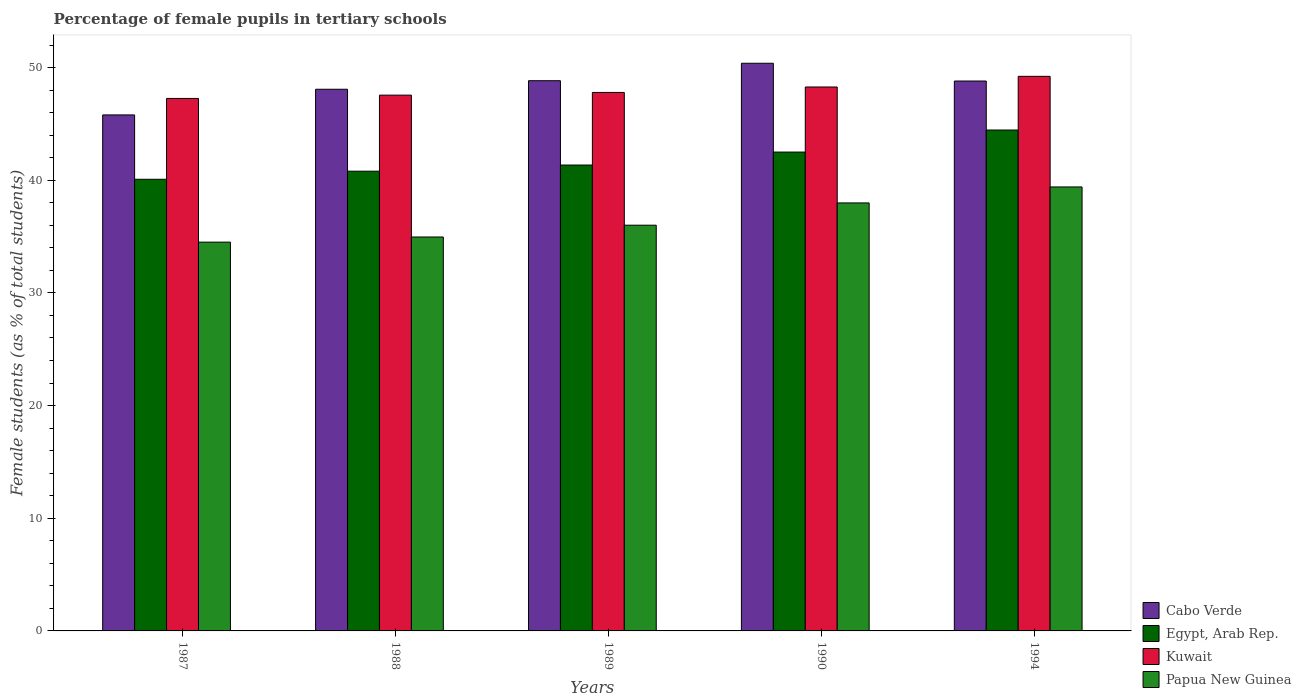Are the number of bars per tick equal to the number of legend labels?
Keep it short and to the point. Yes. Are the number of bars on each tick of the X-axis equal?
Keep it short and to the point. Yes. How many bars are there on the 3rd tick from the left?
Provide a succinct answer. 4. In how many cases, is the number of bars for a given year not equal to the number of legend labels?
Offer a very short reply. 0. What is the percentage of female pupils in tertiary schools in Papua New Guinea in 1990?
Provide a succinct answer. 37.99. Across all years, what is the maximum percentage of female pupils in tertiary schools in Papua New Guinea?
Provide a short and direct response. 39.4. Across all years, what is the minimum percentage of female pupils in tertiary schools in Papua New Guinea?
Provide a succinct answer. 34.51. In which year was the percentage of female pupils in tertiary schools in Kuwait maximum?
Your response must be concise. 1994. In which year was the percentage of female pupils in tertiary schools in Papua New Guinea minimum?
Offer a terse response. 1987. What is the total percentage of female pupils in tertiary schools in Papua New Guinea in the graph?
Give a very brief answer. 182.87. What is the difference between the percentage of female pupils in tertiary schools in Egypt, Arab Rep. in 1989 and that in 1994?
Ensure brevity in your answer.  -3.11. What is the difference between the percentage of female pupils in tertiary schools in Cabo Verde in 1994 and the percentage of female pupils in tertiary schools in Papua New Guinea in 1990?
Ensure brevity in your answer.  10.82. What is the average percentage of female pupils in tertiary schools in Papua New Guinea per year?
Keep it short and to the point. 36.57. In the year 1990, what is the difference between the percentage of female pupils in tertiary schools in Kuwait and percentage of female pupils in tertiary schools in Cabo Verde?
Make the answer very short. -2.11. What is the ratio of the percentage of female pupils in tertiary schools in Egypt, Arab Rep. in 1987 to that in 1994?
Give a very brief answer. 0.9. Is the percentage of female pupils in tertiary schools in Egypt, Arab Rep. in 1987 less than that in 1990?
Your answer should be compact. Yes. What is the difference between the highest and the second highest percentage of female pupils in tertiary schools in Egypt, Arab Rep.?
Give a very brief answer. 1.96. What is the difference between the highest and the lowest percentage of female pupils in tertiary schools in Kuwait?
Make the answer very short. 1.96. In how many years, is the percentage of female pupils in tertiary schools in Papua New Guinea greater than the average percentage of female pupils in tertiary schools in Papua New Guinea taken over all years?
Offer a very short reply. 2. Is the sum of the percentage of female pupils in tertiary schools in Cabo Verde in 1988 and 1990 greater than the maximum percentage of female pupils in tertiary schools in Egypt, Arab Rep. across all years?
Your answer should be very brief. Yes. What does the 4th bar from the left in 1994 represents?
Your answer should be very brief. Papua New Guinea. What does the 2nd bar from the right in 1988 represents?
Keep it short and to the point. Kuwait. How many bars are there?
Keep it short and to the point. 20. How many years are there in the graph?
Give a very brief answer. 5. What is the difference between two consecutive major ticks on the Y-axis?
Give a very brief answer. 10. Does the graph contain any zero values?
Provide a short and direct response. No. Does the graph contain grids?
Make the answer very short. No. What is the title of the graph?
Offer a very short reply. Percentage of female pupils in tertiary schools. What is the label or title of the X-axis?
Provide a succinct answer. Years. What is the label or title of the Y-axis?
Make the answer very short. Female students (as % of total students). What is the Female students (as % of total students) in Cabo Verde in 1987?
Provide a succinct answer. 45.8. What is the Female students (as % of total students) of Egypt, Arab Rep. in 1987?
Your response must be concise. 40.08. What is the Female students (as % of total students) in Kuwait in 1987?
Offer a terse response. 47.26. What is the Female students (as % of total students) in Papua New Guinea in 1987?
Ensure brevity in your answer.  34.51. What is the Female students (as % of total students) in Cabo Verde in 1988?
Give a very brief answer. 48.07. What is the Female students (as % of total students) of Egypt, Arab Rep. in 1988?
Offer a terse response. 40.8. What is the Female students (as % of total students) in Kuwait in 1988?
Offer a very short reply. 47.55. What is the Female students (as % of total students) in Papua New Guinea in 1988?
Your answer should be very brief. 34.96. What is the Female students (as % of total students) in Cabo Verde in 1989?
Offer a very short reply. 48.83. What is the Female students (as % of total students) in Egypt, Arab Rep. in 1989?
Keep it short and to the point. 41.35. What is the Female students (as % of total students) of Kuwait in 1989?
Keep it short and to the point. 47.79. What is the Female students (as % of total students) in Papua New Guinea in 1989?
Provide a succinct answer. 36.01. What is the Female students (as % of total students) of Cabo Verde in 1990?
Your response must be concise. 50.38. What is the Female students (as % of total students) in Egypt, Arab Rep. in 1990?
Your answer should be compact. 42.5. What is the Female students (as % of total students) of Kuwait in 1990?
Your answer should be very brief. 48.28. What is the Female students (as % of total students) in Papua New Guinea in 1990?
Offer a very short reply. 37.99. What is the Female students (as % of total students) in Cabo Verde in 1994?
Provide a succinct answer. 48.8. What is the Female students (as % of total students) of Egypt, Arab Rep. in 1994?
Provide a succinct answer. 44.46. What is the Female students (as % of total students) in Kuwait in 1994?
Give a very brief answer. 49.22. What is the Female students (as % of total students) in Papua New Guinea in 1994?
Provide a succinct answer. 39.4. Across all years, what is the maximum Female students (as % of total students) in Cabo Verde?
Offer a very short reply. 50.38. Across all years, what is the maximum Female students (as % of total students) in Egypt, Arab Rep.?
Give a very brief answer. 44.46. Across all years, what is the maximum Female students (as % of total students) of Kuwait?
Your answer should be compact. 49.22. Across all years, what is the maximum Female students (as % of total students) of Papua New Guinea?
Offer a terse response. 39.4. Across all years, what is the minimum Female students (as % of total students) in Cabo Verde?
Provide a short and direct response. 45.8. Across all years, what is the minimum Female students (as % of total students) of Egypt, Arab Rep.?
Your response must be concise. 40.08. Across all years, what is the minimum Female students (as % of total students) of Kuwait?
Provide a short and direct response. 47.26. Across all years, what is the minimum Female students (as % of total students) of Papua New Guinea?
Provide a succinct answer. 34.51. What is the total Female students (as % of total students) in Cabo Verde in the graph?
Give a very brief answer. 241.89. What is the total Female students (as % of total students) of Egypt, Arab Rep. in the graph?
Provide a short and direct response. 209.19. What is the total Female students (as % of total students) of Kuwait in the graph?
Your answer should be very brief. 240.1. What is the total Female students (as % of total students) in Papua New Guinea in the graph?
Your answer should be very brief. 182.87. What is the difference between the Female students (as % of total students) in Cabo Verde in 1987 and that in 1988?
Provide a short and direct response. -2.28. What is the difference between the Female students (as % of total students) in Egypt, Arab Rep. in 1987 and that in 1988?
Provide a succinct answer. -0.72. What is the difference between the Female students (as % of total students) in Kuwait in 1987 and that in 1988?
Keep it short and to the point. -0.29. What is the difference between the Female students (as % of total students) of Papua New Guinea in 1987 and that in 1988?
Your answer should be very brief. -0.46. What is the difference between the Female students (as % of total students) of Cabo Verde in 1987 and that in 1989?
Your response must be concise. -3.03. What is the difference between the Female students (as % of total students) in Egypt, Arab Rep. in 1987 and that in 1989?
Make the answer very short. -1.26. What is the difference between the Female students (as % of total students) in Kuwait in 1987 and that in 1989?
Your answer should be compact. -0.53. What is the difference between the Female students (as % of total students) in Papua New Guinea in 1987 and that in 1989?
Your response must be concise. -1.5. What is the difference between the Female students (as % of total students) of Cabo Verde in 1987 and that in 1990?
Ensure brevity in your answer.  -4.58. What is the difference between the Female students (as % of total students) of Egypt, Arab Rep. in 1987 and that in 1990?
Offer a very short reply. -2.42. What is the difference between the Female students (as % of total students) in Kuwait in 1987 and that in 1990?
Give a very brief answer. -1.02. What is the difference between the Female students (as % of total students) of Papua New Guinea in 1987 and that in 1990?
Provide a succinct answer. -3.48. What is the difference between the Female students (as % of total students) in Cabo Verde in 1987 and that in 1994?
Make the answer very short. -3.01. What is the difference between the Female students (as % of total students) in Egypt, Arab Rep. in 1987 and that in 1994?
Make the answer very short. -4.37. What is the difference between the Female students (as % of total students) in Kuwait in 1987 and that in 1994?
Ensure brevity in your answer.  -1.96. What is the difference between the Female students (as % of total students) of Papua New Guinea in 1987 and that in 1994?
Make the answer very short. -4.9. What is the difference between the Female students (as % of total students) of Cabo Verde in 1988 and that in 1989?
Make the answer very short. -0.76. What is the difference between the Female students (as % of total students) of Egypt, Arab Rep. in 1988 and that in 1989?
Your answer should be very brief. -0.55. What is the difference between the Female students (as % of total students) of Kuwait in 1988 and that in 1989?
Ensure brevity in your answer.  -0.24. What is the difference between the Female students (as % of total students) of Papua New Guinea in 1988 and that in 1989?
Provide a succinct answer. -1.05. What is the difference between the Female students (as % of total students) of Cabo Verde in 1988 and that in 1990?
Your answer should be compact. -2.31. What is the difference between the Female students (as % of total students) in Egypt, Arab Rep. in 1988 and that in 1990?
Provide a short and direct response. -1.7. What is the difference between the Female students (as % of total students) of Kuwait in 1988 and that in 1990?
Give a very brief answer. -0.72. What is the difference between the Female students (as % of total students) of Papua New Guinea in 1988 and that in 1990?
Make the answer very short. -3.02. What is the difference between the Female students (as % of total students) in Cabo Verde in 1988 and that in 1994?
Give a very brief answer. -0.73. What is the difference between the Female students (as % of total students) in Egypt, Arab Rep. in 1988 and that in 1994?
Keep it short and to the point. -3.65. What is the difference between the Female students (as % of total students) of Kuwait in 1988 and that in 1994?
Your answer should be compact. -1.67. What is the difference between the Female students (as % of total students) of Papua New Guinea in 1988 and that in 1994?
Your response must be concise. -4.44. What is the difference between the Female students (as % of total students) of Cabo Verde in 1989 and that in 1990?
Provide a succinct answer. -1.55. What is the difference between the Female students (as % of total students) of Egypt, Arab Rep. in 1989 and that in 1990?
Offer a very short reply. -1.15. What is the difference between the Female students (as % of total students) in Kuwait in 1989 and that in 1990?
Make the answer very short. -0.48. What is the difference between the Female students (as % of total students) of Papua New Guinea in 1989 and that in 1990?
Offer a terse response. -1.98. What is the difference between the Female students (as % of total students) in Cabo Verde in 1989 and that in 1994?
Ensure brevity in your answer.  0.03. What is the difference between the Female students (as % of total students) of Egypt, Arab Rep. in 1989 and that in 1994?
Give a very brief answer. -3.11. What is the difference between the Female students (as % of total students) in Kuwait in 1989 and that in 1994?
Make the answer very short. -1.43. What is the difference between the Female students (as % of total students) of Papua New Guinea in 1989 and that in 1994?
Ensure brevity in your answer.  -3.39. What is the difference between the Female students (as % of total students) in Cabo Verde in 1990 and that in 1994?
Offer a terse response. 1.58. What is the difference between the Female students (as % of total students) in Egypt, Arab Rep. in 1990 and that in 1994?
Keep it short and to the point. -1.96. What is the difference between the Female students (as % of total students) in Kuwait in 1990 and that in 1994?
Your answer should be compact. -0.95. What is the difference between the Female students (as % of total students) in Papua New Guinea in 1990 and that in 1994?
Keep it short and to the point. -1.42. What is the difference between the Female students (as % of total students) of Cabo Verde in 1987 and the Female students (as % of total students) of Egypt, Arab Rep. in 1988?
Ensure brevity in your answer.  5. What is the difference between the Female students (as % of total students) in Cabo Verde in 1987 and the Female students (as % of total students) in Kuwait in 1988?
Your answer should be compact. -1.76. What is the difference between the Female students (as % of total students) of Cabo Verde in 1987 and the Female students (as % of total students) of Papua New Guinea in 1988?
Make the answer very short. 10.84. What is the difference between the Female students (as % of total students) of Egypt, Arab Rep. in 1987 and the Female students (as % of total students) of Kuwait in 1988?
Offer a very short reply. -7.47. What is the difference between the Female students (as % of total students) of Egypt, Arab Rep. in 1987 and the Female students (as % of total students) of Papua New Guinea in 1988?
Offer a very short reply. 5.12. What is the difference between the Female students (as % of total students) in Kuwait in 1987 and the Female students (as % of total students) in Papua New Guinea in 1988?
Ensure brevity in your answer.  12.3. What is the difference between the Female students (as % of total students) of Cabo Verde in 1987 and the Female students (as % of total students) of Egypt, Arab Rep. in 1989?
Make the answer very short. 4.45. What is the difference between the Female students (as % of total students) in Cabo Verde in 1987 and the Female students (as % of total students) in Kuwait in 1989?
Your answer should be very brief. -1.99. What is the difference between the Female students (as % of total students) of Cabo Verde in 1987 and the Female students (as % of total students) of Papua New Guinea in 1989?
Your answer should be very brief. 9.79. What is the difference between the Female students (as % of total students) of Egypt, Arab Rep. in 1987 and the Female students (as % of total students) of Kuwait in 1989?
Your answer should be compact. -7.71. What is the difference between the Female students (as % of total students) in Egypt, Arab Rep. in 1987 and the Female students (as % of total students) in Papua New Guinea in 1989?
Offer a terse response. 4.07. What is the difference between the Female students (as % of total students) of Kuwait in 1987 and the Female students (as % of total students) of Papua New Guinea in 1989?
Ensure brevity in your answer.  11.25. What is the difference between the Female students (as % of total students) of Cabo Verde in 1987 and the Female students (as % of total students) of Egypt, Arab Rep. in 1990?
Give a very brief answer. 3.3. What is the difference between the Female students (as % of total students) in Cabo Verde in 1987 and the Female students (as % of total students) in Kuwait in 1990?
Make the answer very short. -2.48. What is the difference between the Female students (as % of total students) of Cabo Verde in 1987 and the Female students (as % of total students) of Papua New Guinea in 1990?
Offer a terse response. 7.81. What is the difference between the Female students (as % of total students) of Egypt, Arab Rep. in 1987 and the Female students (as % of total students) of Kuwait in 1990?
Give a very brief answer. -8.19. What is the difference between the Female students (as % of total students) of Egypt, Arab Rep. in 1987 and the Female students (as % of total students) of Papua New Guinea in 1990?
Make the answer very short. 2.1. What is the difference between the Female students (as % of total students) of Kuwait in 1987 and the Female students (as % of total students) of Papua New Guinea in 1990?
Give a very brief answer. 9.27. What is the difference between the Female students (as % of total students) in Cabo Verde in 1987 and the Female students (as % of total students) in Egypt, Arab Rep. in 1994?
Give a very brief answer. 1.34. What is the difference between the Female students (as % of total students) in Cabo Verde in 1987 and the Female students (as % of total students) in Kuwait in 1994?
Your answer should be very brief. -3.42. What is the difference between the Female students (as % of total students) in Cabo Verde in 1987 and the Female students (as % of total students) in Papua New Guinea in 1994?
Your answer should be very brief. 6.39. What is the difference between the Female students (as % of total students) in Egypt, Arab Rep. in 1987 and the Female students (as % of total students) in Kuwait in 1994?
Ensure brevity in your answer.  -9.14. What is the difference between the Female students (as % of total students) in Egypt, Arab Rep. in 1987 and the Female students (as % of total students) in Papua New Guinea in 1994?
Provide a short and direct response. 0.68. What is the difference between the Female students (as % of total students) in Kuwait in 1987 and the Female students (as % of total students) in Papua New Guinea in 1994?
Your answer should be very brief. 7.86. What is the difference between the Female students (as % of total students) in Cabo Verde in 1988 and the Female students (as % of total students) in Egypt, Arab Rep. in 1989?
Make the answer very short. 6.73. What is the difference between the Female students (as % of total students) in Cabo Verde in 1988 and the Female students (as % of total students) in Kuwait in 1989?
Your response must be concise. 0.28. What is the difference between the Female students (as % of total students) of Cabo Verde in 1988 and the Female students (as % of total students) of Papua New Guinea in 1989?
Your answer should be very brief. 12.06. What is the difference between the Female students (as % of total students) in Egypt, Arab Rep. in 1988 and the Female students (as % of total students) in Kuwait in 1989?
Offer a terse response. -6.99. What is the difference between the Female students (as % of total students) of Egypt, Arab Rep. in 1988 and the Female students (as % of total students) of Papua New Guinea in 1989?
Provide a short and direct response. 4.79. What is the difference between the Female students (as % of total students) in Kuwait in 1988 and the Female students (as % of total students) in Papua New Guinea in 1989?
Provide a short and direct response. 11.54. What is the difference between the Female students (as % of total students) of Cabo Verde in 1988 and the Female students (as % of total students) of Egypt, Arab Rep. in 1990?
Provide a short and direct response. 5.57. What is the difference between the Female students (as % of total students) in Cabo Verde in 1988 and the Female students (as % of total students) in Kuwait in 1990?
Provide a short and direct response. -0.2. What is the difference between the Female students (as % of total students) of Cabo Verde in 1988 and the Female students (as % of total students) of Papua New Guinea in 1990?
Provide a succinct answer. 10.09. What is the difference between the Female students (as % of total students) in Egypt, Arab Rep. in 1988 and the Female students (as % of total students) in Kuwait in 1990?
Make the answer very short. -7.47. What is the difference between the Female students (as % of total students) in Egypt, Arab Rep. in 1988 and the Female students (as % of total students) in Papua New Guinea in 1990?
Ensure brevity in your answer.  2.82. What is the difference between the Female students (as % of total students) of Kuwait in 1988 and the Female students (as % of total students) of Papua New Guinea in 1990?
Your response must be concise. 9.57. What is the difference between the Female students (as % of total students) in Cabo Verde in 1988 and the Female students (as % of total students) in Egypt, Arab Rep. in 1994?
Your answer should be very brief. 3.62. What is the difference between the Female students (as % of total students) in Cabo Verde in 1988 and the Female students (as % of total students) in Kuwait in 1994?
Your response must be concise. -1.15. What is the difference between the Female students (as % of total students) of Cabo Verde in 1988 and the Female students (as % of total students) of Papua New Guinea in 1994?
Your answer should be very brief. 8.67. What is the difference between the Female students (as % of total students) in Egypt, Arab Rep. in 1988 and the Female students (as % of total students) in Kuwait in 1994?
Give a very brief answer. -8.42. What is the difference between the Female students (as % of total students) in Egypt, Arab Rep. in 1988 and the Female students (as % of total students) in Papua New Guinea in 1994?
Your answer should be very brief. 1.4. What is the difference between the Female students (as % of total students) in Kuwait in 1988 and the Female students (as % of total students) in Papua New Guinea in 1994?
Provide a succinct answer. 8.15. What is the difference between the Female students (as % of total students) of Cabo Verde in 1989 and the Female students (as % of total students) of Egypt, Arab Rep. in 1990?
Offer a very short reply. 6.33. What is the difference between the Female students (as % of total students) in Cabo Verde in 1989 and the Female students (as % of total students) in Kuwait in 1990?
Provide a succinct answer. 0.56. What is the difference between the Female students (as % of total students) of Cabo Verde in 1989 and the Female students (as % of total students) of Papua New Guinea in 1990?
Provide a short and direct response. 10.85. What is the difference between the Female students (as % of total students) in Egypt, Arab Rep. in 1989 and the Female students (as % of total students) in Kuwait in 1990?
Your answer should be compact. -6.93. What is the difference between the Female students (as % of total students) of Egypt, Arab Rep. in 1989 and the Female students (as % of total students) of Papua New Guinea in 1990?
Keep it short and to the point. 3.36. What is the difference between the Female students (as % of total students) of Kuwait in 1989 and the Female students (as % of total students) of Papua New Guinea in 1990?
Offer a very short reply. 9.8. What is the difference between the Female students (as % of total students) of Cabo Verde in 1989 and the Female students (as % of total students) of Egypt, Arab Rep. in 1994?
Ensure brevity in your answer.  4.38. What is the difference between the Female students (as % of total students) in Cabo Verde in 1989 and the Female students (as % of total students) in Kuwait in 1994?
Your response must be concise. -0.39. What is the difference between the Female students (as % of total students) of Cabo Verde in 1989 and the Female students (as % of total students) of Papua New Guinea in 1994?
Provide a short and direct response. 9.43. What is the difference between the Female students (as % of total students) in Egypt, Arab Rep. in 1989 and the Female students (as % of total students) in Kuwait in 1994?
Your answer should be very brief. -7.87. What is the difference between the Female students (as % of total students) in Egypt, Arab Rep. in 1989 and the Female students (as % of total students) in Papua New Guinea in 1994?
Ensure brevity in your answer.  1.94. What is the difference between the Female students (as % of total students) in Kuwait in 1989 and the Female students (as % of total students) in Papua New Guinea in 1994?
Keep it short and to the point. 8.39. What is the difference between the Female students (as % of total students) of Cabo Verde in 1990 and the Female students (as % of total students) of Egypt, Arab Rep. in 1994?
Offer a very short reply. 5.93. What is the difference between the Female students (as % of total students) in Cabo Verde in 1990 and the Female students (as % of total students) in Kuwait in 1994?
Your response must be concise. 1.16. What is the difference between the Female students (as % of total students) in Cabo Verde in 1990 and the Female students (as % of total students) in Papua New Guinea in 1994?
Provide a succinct answer. 10.98. What is the difference between the Female students (as % of total students) in Egypt, Arab Rep. in 1990 and the Female students (as % of total students) in Kuwait in 1994?
Your answer should be compact. -6.72. What is the difference between the Female students (as % of total students) in Egypt, Arab Rep. in 1990 and the Female students (as % of total students) in Papua New Guinea in 1994?
Your response must be concise. 3.1. What is the difference between the Female students (as % of total students) of Kuwait in 1990 and the Female students (as % of total students) of Papua New Guinea in 1994?
Your response must be concise. 8.87. What is the average Female students (as % of total students) of Cabo Verde per year?
Make the answer very short. 48.38. What is the average Female students (as % of total students) in Egypt, Arab Rep. per year?
Make the answer very short. 41.84. What is the average Female students (as % of total students) of Kuwait per year?
Offer a terse response. 48.02. What is the average Female students (as % of total students) of Papua New Guinea per year?
Provide a short and direct response. 36.57. In the year 1987, what is the difference between the Female students (as % of total students) in Cabo Verde and Female students (as % of total students) in Egypt, Arab Rep.?
Provide a succinct answer. 5.71. In the year 1987, what is the difference between the Female students (as % of total students) of Cabo Verde and Female students (as % of total students) of Kuwait?
Provide a succinct answer. -1.46. In the year 1987, what is the difference between the Female students (as % of total students) in Cabo Verde and Female students (as % of total students) in Papua New Guinea?
Keep it short and to the point. 11.29. In the year 1987, what is the difference between the Female students (as % of total students) of Egypt, Arab Rep. and Female students (as % of total students) of Kuwait?
Give a very brief answer. -7.17. In the year 1987, what is the difference between the Female students (as % of total students) of Egypt, Arab Rep. and Female students (as % of total students) of Papua New Guinea?
Make the answer very short. 5.58. In the year 1987, what is the difference between the Female students (as % of total students) in Kuwait and Female students (as % of total students) in Papua New Guinea?
Provide a short and direct response. 12.75. In the year 1988, what is the difference between the Female students (as % of total students) of Cabo Verde and Female students (as % of total students) of Egypt, Arab Rep.?
Offer a terse response. 7.27. In the year 1988, what is the difference between the Female students (as % of total students) of Cabo Verde and Female students (as % of total students) of Kuwait?
Keep it short and to the point. 0.52. In the year 1988, what is the difference between the Female students (as % of total students) of Cabo Verde and Female students (as % of total students) of Papua New Guinea?
Give a very brief answer. 13.11. In the year 1988, what is the difference between the Female students (as % of total students) in Egypt, Arab Rep. and Female students (as % of total students) in Kuwait?
Ensure brevity in your answer.  -6.75. In the year 1988, what is the difference between the Female students (as % of total students) of Egypt, Arab Rep. and Female students (as % of total students) of Papua New Guinea?
Make the answer very short. 5.84. In the year 1988, what is the difference between the Female students (as % of total students) of Kuwait and Female students (as % of total students) of Papua New Guinea?
Ensure brevity in your answer.  12.59. In the year 1989, what is the difference between the Female students (as % of total students) of Cabo Verde and Female students (as % of total students) of Egypt, Arab Rep.?
Your answer should be compact. 7.48. In the year 1989, what is the difference between the Female students (as % of total students) in Cabo Verde and Female students (as % of total students) in Kuwait?
Keep it short and to the point. 1.04. In the year 1989, what is the difference between the Female students (as % of total students) in Cabo Verde and Female students (as % of total students) in Papua New Guinea?
Your answer should be very brief. 12.82. In the year 1989, what is the difference between the Female students (as % of total students) of Egypt, Arab Rep. and Female students (as % of total students) of Kuwait?
Provide a succinct answer. -6.44. In the year 1989, what is the difference between the Female students (as % of total students) of Egypt, Arab Rep. and Female students (as % of total students) of Papua New Guinea?
Offer a terse response. 5.34. In the year 1989, what is the difference between the Female students (as % of total students) in Kuwait and Female students (as % of total students) in Papua New Guinea?
Your answer should be compact. 11.78. In the year 1990, what is the difference between the Female students (as % of total students) of Cabo Verde and Female students (as % of total students) of Egypt, Arab Rep.?
Keep it short and to the point. 7.88. In the year 1990, what is the difference between the Female students (as % of total students) in Cabo Verde and Female students (as % of total students) in Kuwait?
Offer a very short reply. 2.11. In the year 1990, what is the difference between the Female students (as % of total students) of Cabo Verde and Female students (as % of total students) of Papua New Guinea?
Keep it short and to the point. 12.4. In the year 1990, what is the difference between the Female students (as % of total students) of Egypt, Arab Rep. and Female students (as % of total students) of Kuwait?
Provide a short and direct response. -5.78. In the year 1990, what is the difference between the Female students (as % of total students) of Egypt, Arab Rep. and Female students (as % of total students) of Papua New Guinea?
Your answer should be compact. 4.51. In the year 1990, what is the difference between the Female students (as % of total students) of Kuwait and Female students (as % of total students) of Papua New Guinea?
Offer a terse response. 10.29. In the year 1994, what is the difference between the Female students (as % of total students) in Cabo Verde and Female students (as % of total students) in Egypt, Arab Rep.?
Ensure brevity in your answer.  4.35. In the year 1994, what is the difference between the Female students (as % of total students) of Cabo Verde and Female students (as % of total students) of Kuwait?
Your response must be concise. -0.42. In the year 1994, what is the difference between the Female students (as % of total students) of Cabo Verde and Female students (as % of total students) of Papua New Guinea?
Your answer should be compact. 9.4. In the year 1994, what is the difference between the Female students (as % of total students) of Egypt, Arab Rep. and Female students (as % of total students) of Kuwait?
Offer a terse response. -4.77. In the year 1994, what is the difference between the Female students (as % of total students) of Egypt, Arab Rep. and Female students (as % of total students) of Papua New Guinea?
Offer a very short reply. 5.05. In the year 1994, what is the difference between the Female students (as % of total students) of Kuwait and Female students (as % of total students) of Papua New Guinea?
Provide a short and direct response. 9.82. What is the ratio of the Female students (as % of total students) of Cabo Verde in 1987 to that in 1988?
Make the answer very short. 0.95. What is the ratio of the Female students (as % of total students) in Egypt, Arab Rep. in 1987 to that in 1988?
Keep it short and to the point. 0.98. What is the ratio of the Female students (as % of total students) in Papua New Guinea in 1987 to that in 1988?
Provide a short and direct response. 0.99. What is the ratio of the Female students (as % of total students) in Cabo Verde in 1987 to that in 1989?
Provide a succinct answer. 0.94. What is the ratio of the Female students (as % of total students) in Egypt, Arab Rep. in 1987 to that in 1989?
Ensure brevity in your answer.  0.97. What is the ratio of the Female students (as % of total students) of Kuwait in 1987 to that in 1989?
Keep it short and to the point. 0.99. What is the ratio of the Female students (as % of total students) of Cabo Verde in 1987 to that in 1990?
Offer a very short reply. 0.91. What is the ratio of the Female students (as % of total students) in Egypt, Arab Rep. in 1987 to that in 1990?
Your response must be concise. 0.94. What is the ratio of the Female students (as % of total students) in Kuwait in 1987 to that in 1990?
Make the answer very short. 0.98. What is the ratio of the Female students (as % of total students) in Papua New Guinea in 1987 to that in 1990?
Provide a succinct answer. 0.91. What is the ratio of the Female students (as % of total students) of Cabo Verde in 1987 to that in 1994?
Provide a succinct answer. 0.94. What is the ratio of the Female students (as % of total students) of Egypt, Arab Rep. in 1987 to that in 1994?
Keep it short and to the point. 0.9. What is the ratio of the Female students (as % of total students) in Kuwait in 1987 to that in 1994?
Keep it short and to the point. 0.96. What is the ratio of the Female students (as % of total students) of Papua New Guinea in 1987 to that in 1994?
Your answer should be compact. 0.88. What is the ratio of the Female students (as % of total students) of Cabo Verde in 1988 to that in 1989?
Make the answer very short. 0.98. What is the ratio of the Female students (as % of total students) in Egypt, Arab Rep. in 1988 to that in 1989?
Offer a very short reply. 0.99. What is the ratio of the Female students (as % of total students) in Papua New Guinea in 1988 to that in 1989?
Ensure brevity in your answer.  0.97. What is the ratio of the Female students (as % of total students) of Cabo Verde in 1988 to that in 1990?
Your response must be concise. 0.95. What is the ratio of the Female students (as % of total students) of Egypt, Arab Rep. in 1988 to that in 1990?
Your answer should be compact. 0.96. What is the ratio of the Female students (as % of total students) of Papua New Guinea in 1988 to that in 1990?
Give a very brief answer. 0.92. What is the ratio of the Female students (as % of total students) of Cabo Verde in 1988 to that in 1994?
Your answer should be compact. 0.98. What is the ratio of the Female students (as % of total students) of Egypt, Arab Rep. in 1988 to that in 1994?
Provide a short and direct response. 0.92. What is the ratio of the Female students (as % of total students) of Kuwait in 1988 to that in 1994?
Provide a succinct answer. 0.97. What is the ratio of the Female students (as % of total students) of Papua New Guinea in 1988 to that in 1994?
Your answer should be compact. 0.89. What is the ratio of the Female students (as % of total students) of Cabo Verde in 1989 to that in 1990?
Provide a succinct answer. 0.97. What is the ratio of the Female students (as % of total students) of Egypt, Arab Rep. in 1989 to that in 1990?
Keep it short and to the point. 0.97. What is the ratio of the Female students (as % of total students) of Kuwait in 1989 to that in 1990?
Provide a short and direct response. 0.99. What is the ratio of the Female students (as % of total students) of Papua New Guinea in 1989 to that in 1990?
Your answer should be compact. 0.95. What is the ratio of the Female students (as % of total students) in Egypt, Arab Rep. in 1989 to that in 1994?
Your answer should be very brief. 0.93. What is the ratio of the Female students (as % of total students) in Kuwait in 1989 to that in 1994?
Your answer should be compact. 0.97. What is the ratio of the Female students (as % of total students) in Papua New Guinea in 1989 to that in 1994?
Ensure brevity in your answer.  0.91. What is the ratio of the Female students (as % of total students) of Cabo Verde in 1990 to that in 1994?
Offer a very short reply. 1.03. What is the ratio of the Female students (as % of total students) in Egypt, Arab Rep. in 1990 to that in 1994?
Your response must be concise. 0.96. What is the ratio of the Female students (as % of total students) in Kuwait in 1990 to that in 1994?
Give a very brief answer. 0.98. What is the difference between the highest and the second highest Female students (as % of total students) in Cabo Verde?
Provide a succinct answer. 1.55. What is the difference between the highest and the second highest Female students (as % of total students) of Egypt, Arab Rep.?
Your answer should be very brief. 1.96. What is the difference between the highest and the second highest Female students (as % of total students) in Kuwait?
Your answer should be compact. 0.95. What is the difference between the highest and the second highest Female students (as % of total students) of Papua New Guinea?
Offer a terse response. 1.42. What is the difference between the highest and the lowest Female students (as % of total students) in Cabo Verde?
Your answer should be compact. 4.58. What is the difference between the highest and the lowest Female students (as % of total students) in Egypt, Arab Rep.?
Provide a short and direct response. 4.37. What is the difference between the highest and the lowest Female students (as % of total students) of Kuwait?
Provide a succinct answer. 1.96. What is the difference between the highest and the lowest Female students (as % of total students) in Papua New Guinea?
Provide a succinct answer. 4.9. 